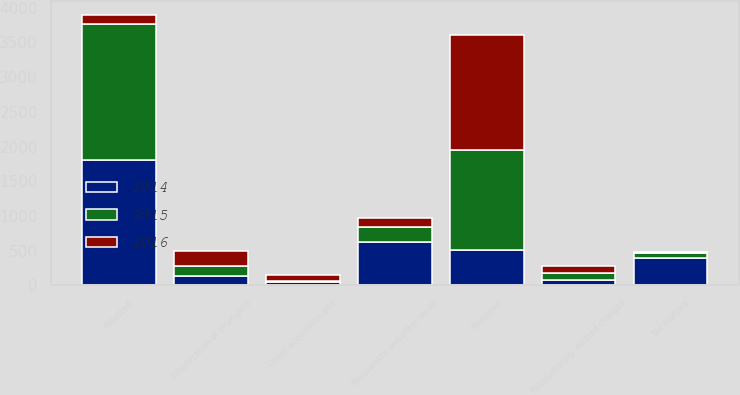<chart> <loc_0><loc_0><loc_500><loc_500><stacked_bar_chart><ecel><fcel>Reported<fcel>Other acquisition and<fcel>Amortization of intangible<fcel>Restructuring- related charges<fcel>Rejuvenate and other recall<fcel>Tax matters<fcel>Adjusted<nl><fcel>2016<fcel>1647<fcel>77<fcel>221<fcel>98<fcel>127<fcel>8<fcel>140<nl><fcel>2015<fcel>1439<fcel>20<fcel>147<fcel>97<fcel>210<fcel>78<fcel>1949<nl><fcel>2014<fcel>515<fcel>50<fcel>133<fcel>78<fcel>628<fcel>391<fcel>1810<nl></chart> 